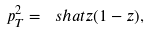Convert formula to latex. <formula><loc_0><loc_0><loc_500><loc_500>p _ { T } ^ { 2 } = \ s h a t z ( 1 - z ) ,</formula> 